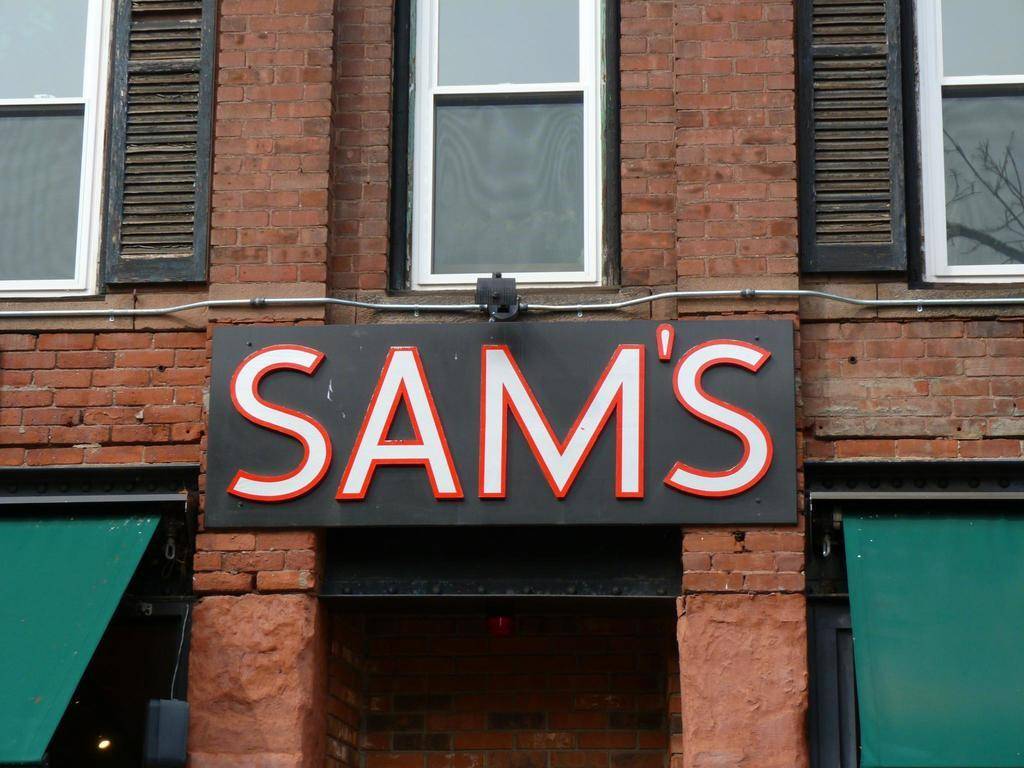<image>
Offer a succinct explanation of the picture presented. A door with a sign above it that says SAM'S. 